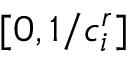<formula> <loc_0><loc_0><loc_500><loc_500>[ 0 , 1 / c _ { i } ^ { r } ]</formula> 